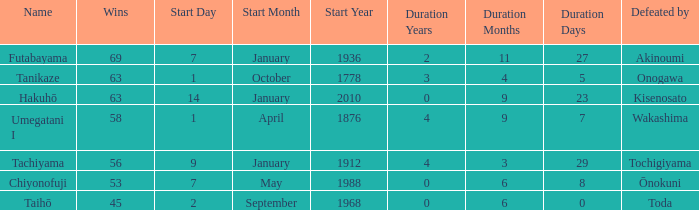What is the Duration for less than 53 consecutive wins? 6 months 0 days. 